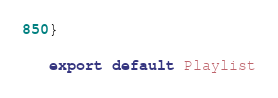Convert code to text. <code><loc_0><loc_0><loc_500><loc_500><_TypeScript_>}

export default Playlist</code> 